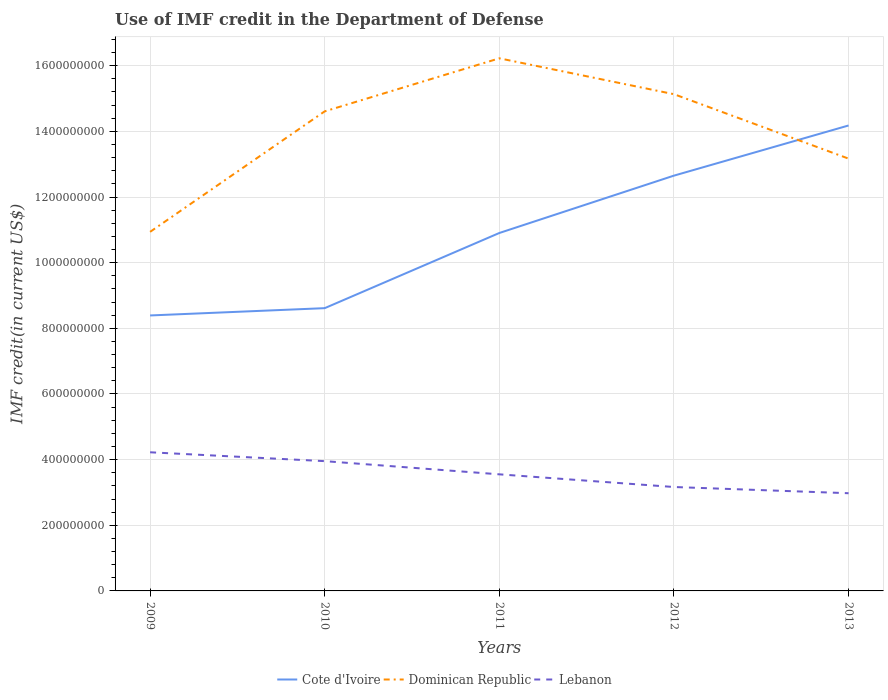How many different coloured lines are there?
Offer a very short reply. 3. Across all years, what is the maximum IMF credit in the Department of Defense in Cote d'Ivoire?
Ensure brevity in your answer.  8.39e+08. In which year was the IMF credit in the Department of Defense in Lebanon maximum?
Provide a succinct answer. 2013. What is the total IMF credit in the Department of Defense in Lebanon in the graph?
Your response must be concise. 5.75e+07. What is the difference between the highest and the second highest IMF credit in the Department of Defense in Cote d'Ivoire?
Give a very brief answer. 5.79e+08. How many lines are there?
Your response must be concise. 3. Are the values on the major ticks of Y-axis written in scientific E-notation?
Ensure brevity in your answer.  No. Does the graph contain any zero values?
Your answer should be compact. No. How many legend labels are there?
Offer a very short reply. 3. How are the legend labels stacked?
Your response must be concise. Horizontal. What is the title of the graph?
Ensure brevity in your answer.  Use of IMF credit in the Department of Defense. What is the label or title of the Y-axis?
Your response must be concise. IMF credit(in current US$). What is the IMF credit(in current US$) of Cote d'Ivoire in 2009?
Make the answer very short. 8.39e+08. What is the IMF credit(in current US$) in Dominican Republic in 2009?
Your response must be concise. 1.09e+09. What is the IMF credit(in current US$) in Lebanon in 2009?
Offer a terse response. 4.22e+08. What is the IMF credit(in current US$) of Cote d'Ivoire in 2010?
Keep it short and to the point. 8.61e+08. What is the IMF credit(in current US$) of Dominican Republic in 2010?
Ensure brevity in your answer.  1.46e+09. What is the IMF credit(in current US$) of Lebanon in 2010?
Provide a short and direct response. 3.95e+08. What is the IMF credit(in current US$) in Cote d'Ivoire in 2011?
Your response must be concise. 1.09e+09. What is the IMF credit(in current US$) of Dominican Republic in 2011?
Offer a very short reply. 1.62e+09. What is the IMF credit(in current US$) in Lebanon in 2011?
Make the answer very short. 3.55e+08. What is the IMF credit(in current US$) of Cote d'Ivoire in 2012?
Your answer should be compact. 1.27e+09. What is the IMF credit(in current US$) of Dominican Republic in 2012?
Offer a very short reply. 1.51e+09. What is the IMF credit(in current US$) of Lebanon in 2012?
Offer a terse response. 3.17e+08. What is the IMF credit(in current US$) in Cote d'Ivoire in 2013?
Offer a very short reply. 1.42e+09. What is the IMF credit(in current US$) in Dominican Republic in 2013?
Offer a terse response. 1.32e+09. What is the IMF credit(in current US$) in Lebanon in 2013?
Provide a short and direct response. 2.98e+08. Across all years, what is the maximum IMF credit(in current US$) of Cote d'Ivoire?
Keep it short and to the point. 1.42e+09. Across all years, what is the maximum IMF credit(in current US$) of Dominican Republic?
Your response must be concise. 1.62e+09. Across all years, what is the maximum IMF credit(in current US$) in Lebanon?
Your answer should be compact. 4.22e+08. Across all years, what is the minimum IMF credit(in current US$) of Cote d'Ivoire?
Your response must be concise. 8.39e+08. Across all years, what is the minimum IMF credit(in current US$) of Dominican Republic?
Your answer should be compact. 1.09e+09. Across all years, what is the minimum IMF credit(in current US$) of Lebanon?
Your answer should be very brief. 2.98e+08. What is the total IMF credit(in current US$) in Cote d'Ivoire in the graph?
Make the answer very short. 5.47e+09. What is the total IMF credit(in current US$) in Dominican Republic in the graph?
Your answer should be compact. 7.01e+09. What is the total IMF credit(in current US$) of Lebanon in the graph?
Give a very brief answer. 1.79e+09. What is the difference between the IMF credit(in current US$) of Cote d'Ivoire in 2009 and that in 2010?
Your response must be concise. -2.23e+07. What is the difference between the IMF credit(in current US$) of Dominican Republic in 2009 and that in 2010?
Keep it short and to the point. -3.67e+08. What is the difference between the IMF credit(in current US$) in Lebanon in 2009 and that in 2010?
Keep it short and to the point. 2.70e+07. What is the difference between the IMF credit(in current US$) in Cote d'Ivoire in 2009 and that in 2011?
Ensure brevity in your answer.  -2.51e+08. What is the difference between the IMF credit(in current US$) of Dominican Republic in 2009 and that in 2011?
Provide a succinct answer. -5.29e+08. What is the difference between the IMF credit(in current US$) in Lebanon in 2009 and that in 2011?
Provide a succinct answer. 6.72e+07. What is the difference between the IMF credit(in current US$) in Cote d'Ivoire in 2009 and that in 2012?
Make the answer very short. -4.26e+08. What is the difference between the IMF credit(in current US$) of Dominican Republic in 2009 and that in 2012?
Your answer should be compact. -4.19e+08. What is the difference between the IMF credit(in current US$) in Lebanon in 2009 and that in 2012?
Provide a short and direct response. 1.06e+08. What is the difference between the IMF credit(in current US$) in Cote d'Ivoire in 2009 and that in 2013?
Your response must be concise. -5.79e+08. What is the difference between the IMF credit(in current US$) in Dominican Republic in 2009 and that in 2013?
Provide a short and direct response. -2.23e+08. What is the difference between the IMF credit(in current US$) in Lebanon in 2009 and that in 2013?
Your answer should be compact. 1.25e+08. What is the difference between the IMF credit(in current US$) of Cote d'Ivoire in 2010 and that in 2011?
Your answer should be very brief. -2.29e+08. What is the difference between the IMF credit(in current US$) in Dominican Republic in 2010 and that in 2011?
Offer a terse response. -1.62e+08. What is the difference between the IMF credit(in current US$) in Lebanon in 2010 and that in 2011?
Your answer should be very brief. 4.02e+07. What is the difference between the IMF credit(in current US$) of Cote d'Ivoire in 2010 and that in 2012?
Make the answer very short. -4.04e+08. What is the difference between the IMF credit(in current US$) of Dominican Republic in 2010 and that in 2012?
Your response must be concise. -5.22e+07. What is the difference between the IMF credit(in current US$) in Lebanon in 2010 and that in 2012?
Keep it short and to the point. 7.88e+07. What is the difference between the IMF credit(in current US$) in Cote d'Ivoire in 2010 and that in 2013?
Ensure brevity in your answer.  -5.57e+08. What is the difference between the IMF credit(in current US$) in Dominican Republic in 2010 and that in 2013?
Offer a very short reply. 1.44e+08. What is the difference between the IMF credit(in current US$) of Lebanon in 2010 and that in 2013?
Offer a terse response. 9.77e+07. What is the difference between the IMF credit(in current US$) of Cote d'Ivoire in 2011 and that in 2012?
Your response must be concise. -1.75e+08. What is the difference between the IMF credit(in current US$) of Dominican Republic in 2011 and that in 2012?
Ensure brevity in your answer.  1.09e+08. What is the difference between the IMF credit(in current US$) in Lebanon in 2011 and that in 2012?
Give a very brief answer. 3.86e+07. What is the difference between the IMF credit(in current US$) in Cote d'Ivoire in 2011 and that in 2013?
Provide a succinct answer. -3.28e+08. What is the difference between the IMF credit(in current US$) in Dominican Republic in 2011 and that in 2013?
Ensure brevity in your answer.  3.06e+08. What is the difference between the IMF credit(in current US$) in Lebanon in 2011 and that in 2013?
Offer a very short reply. 5.75e+07. What is the difference between the IMF credit(in current US$) of Cote d'Ivoire in 2012 and that in 2013?
Your answer should be very brief. -1.53e+08. What is the difference between the IMF credit(in current US$) of Dominican Republic in 2012 and that in 2013?
Offer a terse response. 1.96e+08. What is the difference between the IMF credit(in current US$) of Lebanon in 2012 and that in 2013?
Make the answer very short. 1.89e+07. What is the difference between the IMF credit(in current US$) in Cote d'Ivoire in 2009 and the IMF credit(in current US$) in Dominican Republic in 2010?
Make the answer very short. -6.22e+08. What is the difference between the IMF credit(in current US$) of Cote d'Ivoire in 2009 and the IMF credit(in current US$) of Lebanon in 2010?
Your response must be concise. 4.44e+08. What is the difference between the IMF credit(in current US$) of Dominican Republic in 2009 and the IMF credit(in current US$) of Lebanon in 2010?
Keep it short and to the point. 6.99e+08. What is the difference between the IMF credit(in current US$) of Cote d'Ivoire in 2009 and the IMF credit(in current US$) of Dominican Republic in 2011?
Provide a short and direct response. -7.83e+08. What is the difference between the IMF credit(in current US$) of Cote d'Ivoire in 2009 and the IMF credit(in current US$) of Lebanon in 2011?
Give a very brief answer. 4.84e+08. What is the difference between the IMF credit(in current US$) of Dominican Republic in 2009 and the IMF credit(in current US$) of Lebanon in 2011?
Offer a terse response. 7.39e+08. What is the difference between the IMF credit(in current US$) in Cote d'Ivoire in 2009 and the IMF credit(in current US$) in Dominican Republic in 2012?
Provide a succinct answer. -6.74e+08. What is the difference between the IMF credit(in current US$) in Cote d'Ivoire in 2009 and the IMF credit(in current US$) in Lebanon in 2012?
Your answer should be compact. 5.23e+08. What is the difference between the IMF credit(in current US$) in Dominican Republic in 2009 and the IMF credit(in current US$) in Lebanon in 2012?
Give a very brief answer. 7.77e+08. What is the difference between the IMF credit(in current US$) in Cote d'Ivoire in 2009 and the IMF credit(in current US$) in Dominican Republic in 2013?
Provide a succinct answer. -4.78e+08. What is the difference between the IMF credit(in current US$) in Cote d'Ivoire in 2009 and the IMF credit(in current US$) in Lebanon in 2013?
Keep it short and to the point. 5.42e+08. What is the difference between the IMF credit(in current US$) in Dominican Republic in 2009 and the IMF credit(in current US$) in Lebanon in 2013?
Ensure brevity in your answer.  7.96e+08. What is the difference between the IMF credit(in current US$) of Cote d'Ivoire in 2010 and the IMF credit(in current US$) of Dominican Republic in 2011?
Offer a terse response. -7.61e+08. What is the difference between the IMF credit(in current US$) in Cote d'Ivoire in 2010 and the IMF credit(in current US$) in Lebanon in 2011?
Ensure brevity in your answer.  5.06e+08. What is the difference between the IMF credit(in current US$) of Dominican Republic in 2010 and the IMF credit(in current US$) of Lebanon in 2011?
Ensure brevity in your answer.  1.11e+09. What is the difference between the IMF credit(in current US$) in Cote d'Ivoire in 2010 and the IMF credit(in current US$) in Dominican Republic in 2012?
Make the answer very short. -6.52e+08. What is the difference between the IMF credit(in current US$) in Cote d'Ivoire in 2010 and the IMF credit(in current US$) in Lebanon in 2012?
Make the answer very short. 5.45e+08. What is the difference between the IMF credit(in current US$) of Dominican Republic in 2010 and the IMF credit(in current US$) of Lebanon in 2012?
Provide a succinct answer. 1.14e+09. What is the difference between the IMF credit(in current US$) of Cote d'Ivoire in 2010 and the IMF credit(in current US$) of Dominican Republic in 2013?
Offer a very short reply. -4.56e+08. What is the difference between the IMF credit(in current US$) in Cote d'Ivoire in 2010 and the IMF credit(in current US$) in Lebanon in 2013?
Your answer should be very brief. 5.64e+08. What is the difference between the IMF credit(in current US$) of Dominican Republic in 2010 and the IMF credit(in current US$) of Lebanon in 2013?
Offer a very short reply. 1.16e+09. What is the difference between the IMF credit(in current US$) of Cote d'Ivoire in 2011 and the IMF credit(in current US$) of Dominican Republic in 2012?
Your answer should be very brief. -4.23e+08. What is the difference between the IMF credit(in current US$) of Cote d'Ivoire in 2011 and the IMF credit(in current US$) of Lebanon in 2012?
Provide a short and direct response. 7.74e+08. What is the difference between the IMF credit(in current US$) of Dominican Republic in 2011 and the IMF credit(in current US$) of Lebanon in 2012?
Ensure brevity in your answer.  1.31e+09. What is the difference between the IMF credit(in current US$) in Cote d'Ivoire in 2011 and the IMF credit(in current US$) in Dominican Republic in 2013?
Offer a terse response. -2.27e+08. What is the difference between the IMF credit(in current US$) in Cote d'Ivoire in 2011 and the IMF credit(in current US$) in Lebanon in 2013?
Give a very brief answer. 7.93e+08. What is the difference between the IMF credit(in current US$) of Dominican Republic in 2011 and the IMF credit(in current US$) of Lebanon in 2013?
Your answer should be very brief. 1.32e+09. What is the difference between the IMF credit(in current US$) in Cote d'Ivoire in 2012 and the IMF credit(in current US$) in Dominican Republic in 2013?
Offer a terse response. -5.18e+07. What is the difference between the IMF credit(in current US$) of Cote d'Ivoire in 2012 and the IMF credit(in current US$) of Lebanon in 2013?
Offer a terse response. 9.68e+08. What is the difference between the IMF credit(in current US$) in Dominican Republic in 2012 and the IMF credit(in current US$) in Lebanon in 2013?
Your answer should be very brief. 1.22e+09. What is the average IMF credit(in current US$) of Cote d'Ivoire per year?
Offer a terse response. 1.09e+09. What is the average IMF credit(in current US$) in Dominican Republic per year?
Provide a short and direct response. 1.40e+09. What is the average IMF credit(in current US$) in Lebanon per year?
Give a very brief answer. 3.57e+08. In the year 2009, what is the difference between the IMF credit(in current US$) of Cote d'Ivoire and IMF credit(in current US$) of Dominican Republic?
Offer a very short reply. -2.55e+08. In the year 2009, what is the difference between the IMF credit(in current US$) in Cote d'Ivoire and IMF credit(in current US$) in Lebanon?
Keep it short and to the point. 4.17e+08. In the year 2009, what is the difference between the IMF credit(in current US$) in Dominican Republic and IMF credit(in current US$) in Lebanon?
Offer a very short reply. 6.72e+08. In the year 2010, what is the difference between the IMF credit(in current US$) of Cote d'Ivoire and IMF credit(in current US$) of Dominican Republic?
Provide a succinct answer. -6.00e+08. In the year 2010, what is the difference between the IMF credit(in current US$) of Cote d'Ivoire and IMF credit(in current US$) of Lebanon?
Your answer should be very brief. 4.66e+08. In the year 2010, what is the difference between the IMF credit(in current US$) in Dominican Republic and IMF credit(in current US$) in Lebanon?
Offer a terse response. 1.07e+09. In the year 2011, what is the difference between the IMF credit(in current US$) in Cote d'Ivoire and IMF credit(in current US$) in Dominican Republic?
Give a very brief answer. -5.32e+08. In the year 2011, what is the difference between the IMF credit(in current US$) in Cote d'Ivoire and IMF credit(in current US$) in Lebanon?
Keep it short and to the point. 7.35e+08. In the year 2011, what is the difference between the IMF credit(in current US$) in Dominican Republic and IMF credit(in current US$) in Lebanon?
Provide a succinct answer. 1.27e+09. In the year 2012, what is the difference between the IMF credit(in current US$) in Cote d'Ivoire and IMF credit(in current US$) in Dominican Republic?
Your response must be concise. -2.48e+08. In the year 2012, what is the difference between the IMF credit(in current US$) of Cote d'Ivoire and IMF credit(in current US$) of Lebanon?
Provide a succinct answer. 9.49e+08. In the year 2012, what is the difference between the IMF credit(in current US$) of Dominican Republic and IMF credit(in current US$) of Lebanon?
Your answer should be compact. 1.20e+09. In the year 2013, what is the difference between the IMF credit(in current US$) of Cote d'Ivoire and IMF credit(in current US$) of Dominican Republic?
Make the answer very short. 1.01e+08. In the year 2013, what is the difference between the IMF credit(in current US$) in Cote d'Ivoire and IMF credit(in current US$) in Lebanon?
Your answer should be compact. 1.12e+09. In the year 2013, what is the difference between the IMF credit(in current US$) in Dominican Republic and IMF credit(in current US$) in Lebanon?
Your response must be concise. 1.02e+09. What is the ratio of the IMF credit(in current US$) of Cote d'Ivoire in 2009 to that in 2010?
Your response must be concise. 0.97. What is the ratio of the IMF credit(in current US$) in Dominican Republic in 2009 to that in 2010?
Provide a succinct answer. 0.75. What is the ratio of the IMF credit(in current US$) in Lebanon in 2009 to that in 2010?
Your answer should be compact. 1.07. What is the ratio of the IMF credit(in current US$) of Cote d'Ivoire in 2009 to that in 2011?
Offer a very short reply. 0.77. What is the ratio of the IMF credit(in current US$) of Dominican Republic in 2009 to that in 2011?
Ensure brevity in your answer.  0.67. What is the ratio of the IMF credit(in current US$) of Lebanon in 2009 to that in 2011?
Your answer should be compact. 1.19. What is the ratio of the IMF credit(in current US$) of Cote d'Ivoire in 2009 to that in 2012?
Provide a short and direct response. 0.66. What is the ratio of the IMF credit(in current US$) of Dominican Republic in 2009 to that in 2012?
Provide a short and direct response. 0.72. What is the ratio of the IMF credit(in current US$) in Lebanon in 2009 to that in 2012?
Ensure brevity in your answer.  1.33. What is the ratio of the IMF credit(in current US$) of Cote d'Ivoire in 2009 to that in 2013?
Offer a very short reply. 0.59. What is the ratio of the IMF credit(in current US$) in Dominican Republic in 2009 to that in 2013?
Keep it short and to the point. 0.83. What is the ratio of the IMF credit(in current US$) of Lebanon in 2009 to that in 2013?
Offer a very short reply. 1.42. What is the ratio of the IMF credit(in current US$) in Cote d'Ivoire in 2010 to that in 2011?
Make the answer very short. 0.79. What is the ratio of the IMF credit(in current US$) in Dominican Republic in 2010 to that in 2011?
Your answer should be very brief. 0.9. What is the ratio of the IMF credit(in current US$) of Lebanon in 2010 to that in 2011?
Provide a succinct answer. 1.11. What is the ratio of the IMF credit(in current US$) in Cote d'Ivoire in 2010 to that in 2012?
Offer a very short reply. 0.68. What is the ratio of the IMF credit(in current US$) of Dominican Republic in 2010 to that in 2012?
Make the answer very short. 0.97. What is the ratio of the IMF credit(in current US$) of Lebanon in 2010 to that in 2012?
Provide a succinct answer. 1.25. What is the ratio of the IMF credit(in current US$) of Cote d'Ivoire in 2010 to that in 2013?
Make the answer very short. 0.61. What is the ratio of the IMF credit(in current US$) of Dominican Republic in 2010 to that in 2013?
Your answer should be compact. 1.11. What is the ratio of the IMF credit(in current US$) in Lebanon in 2010 to that in 2013?
Keep it short and to the point. 1.33. What is the ratio of the IMF credit(in current US$) in Cote d'Ivoire in 2011 to that in 2012?
Make the answer very short. 0.86. What is the ratio of the IMF credit(in current US$) in Dominican Republic in 2011 to that in 2012?
Provide a short and direct response. 1.07. What is the ratio of the IMF credit(in current US$) in Lebanon in 2011 to that in 2012?
Give a very brief answer. 1.12. What is the ratio of the IMF credit(in current US$) in Cote d'Ivoire in 2011 to that in 2013?
Provide a succinct answer. 0.77. What is the ratio of the IMF credit(in current US$) of Dominican Republic in 2011 to that in 2013?
Your answer should be very brief. 1.23. What is the ratio of the IMF credit(in current US$) in Lebanon in 2011 to that in 2013?
Give a very brief answer. 1.19. What is the ratio of the IMF credit(in current US$) in Cote d'Ivoire in 2012 to that in 2013?
Offer a very short reply. 0.89. What is the ratio of the IMF credit(in current US$) in Dominican Republic in 2012 to that in 2013?
Ensure brevity in your answer.  1.15. What is the ratio of the IMF credit(in current US$) in Lebanon in 2012 to that in 2013?
Ensure brevity in your answer.  1.06. What is the difference between the highest and the second highest IMF credit(in current US$) in Cote d'Ivoire?
Keep it short and to the point. 1.53e+08. What is the difference between the highest and the second highest IMF credit(in current US$) in Dominican Republic?
Offer a terse response. 1.09e+08. What is the difference between the highest and the second highest IMF credit(in current US$) in Lebanon?
Provide a succinct answer. 2.70e+07. What is the difference between the highest and the lowest IMF credit(in current US$) of Cote d'Ivoire?
Offer a terse response. 5.79e+08. What is the difference between the highest and the lowest IMF credit(in current US$) of Dominican Republic?
Give a very brief answer. 5.29e+08. What is the difference between the highest and the lowest IMF credit(in current US$) in Lebanon?
Offer a terse response. 1.25e+08. 